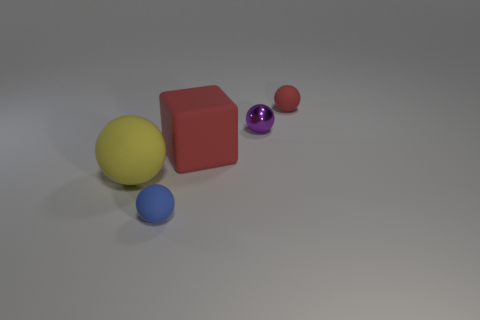Subtract 1 spheres. How many spheres are left? 3 Subtract all rubber spheres. How many spheres are left? 1 Subtract all cyan spheres. Subtract all cyan blocks. How many spheres are left? 4 Add 1 large green cylinders. How many objects exist? 6 Subtract all spheres. How many objects are left? 1 Subtract all small purple metallic spheres. Subtract all large red things. How many objects are left? 3 Add 2 small metal things. How many small metal things are left? 3 Add 2 blue matte things. How many blue matte things exist? 3 Subtract 0 gray spheres. How many objects are left? 5 